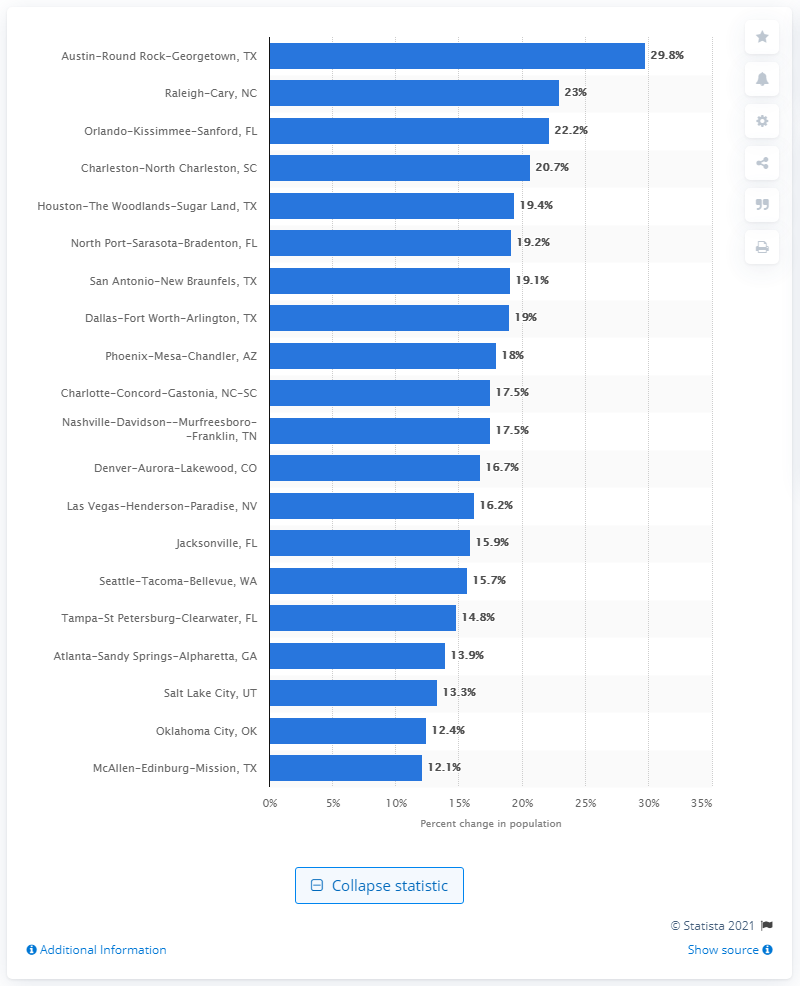Outline some significant characteristics in this image. The population of the Austin-Round Rock-Georgetown area increased by 29.8% from 2010 to 2019. 